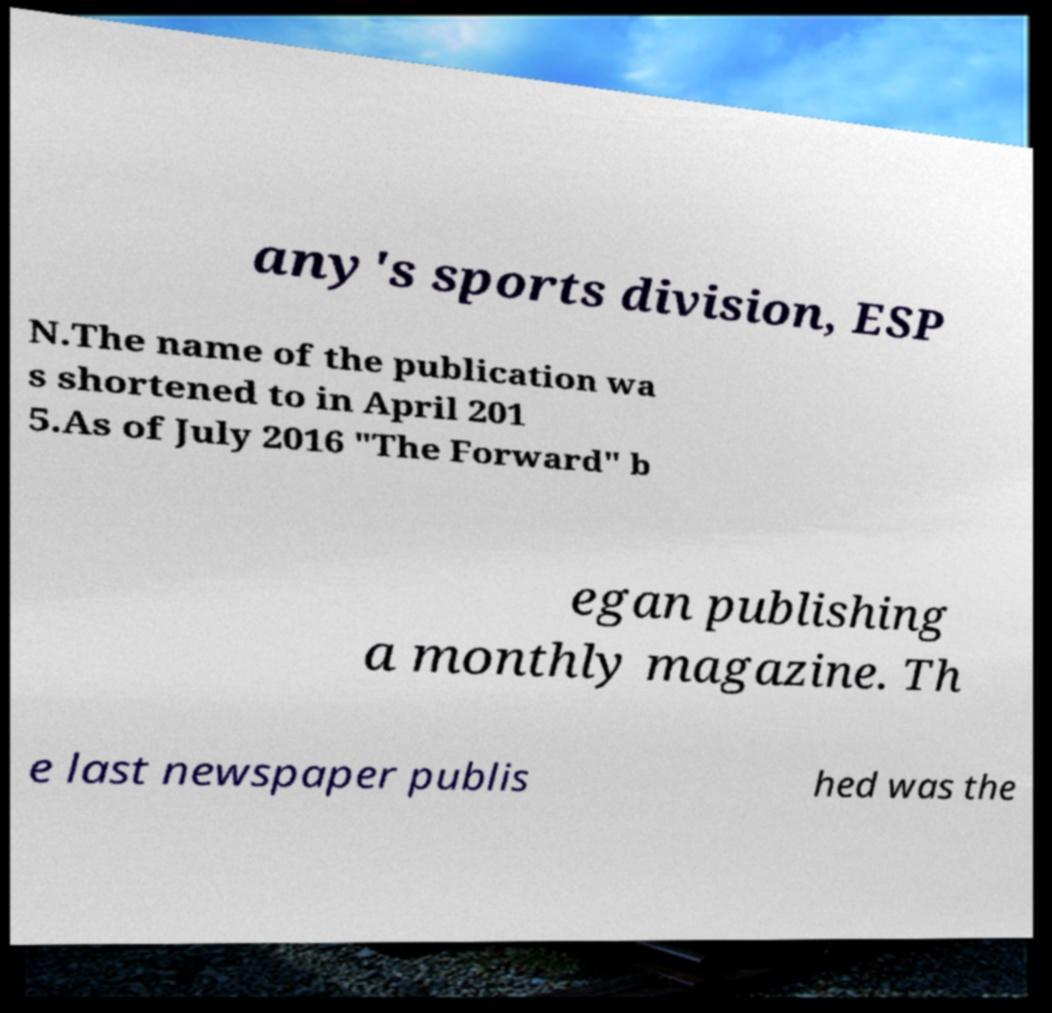I need the written content from this picture converted into text. Can you do that? any's sports division, ESP N.The name of the publication wa s shortened to in April 201 5.As of July 2016 "The Forward" b egan publishing a monthly magazine. Th e last newspaper publis hed was the 